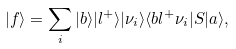<formula> <loc_0><loc_0><loc_500><loc_500>| f \rangle = \sum _ { i } | b \rangle | l ^ { + } \rangle | \nu _ { i } \rangle \langle b l ^ { + } \nu _ { i } | S | a \rangle ,</formula> 